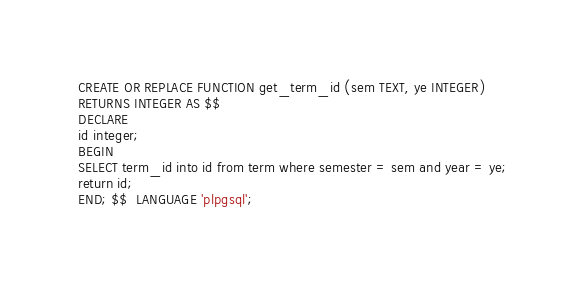Convert code to text. <code><loc_0><loc_0><loc_500><loc_500><_SQL_>CREATE OR REPLACE FUNCTION get_term_id (sem TEXT, ye INTEGER)
RETURNS INTEGER AS $$
DECLARE
id integer;
BEGIN
SELECT term_id into id from term where semester = sem and year = ye;
return id;
END; $$  LANGUAGE 'plpgsql';

</code> 